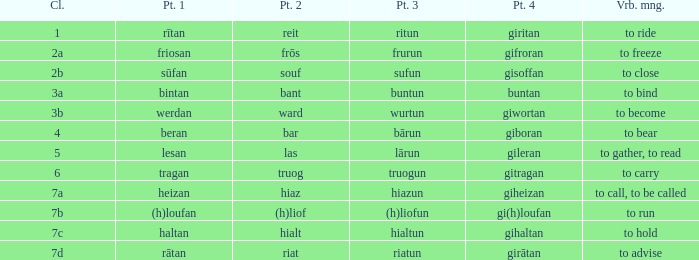What class in the word with part 4 "giheizan"? 7a. 